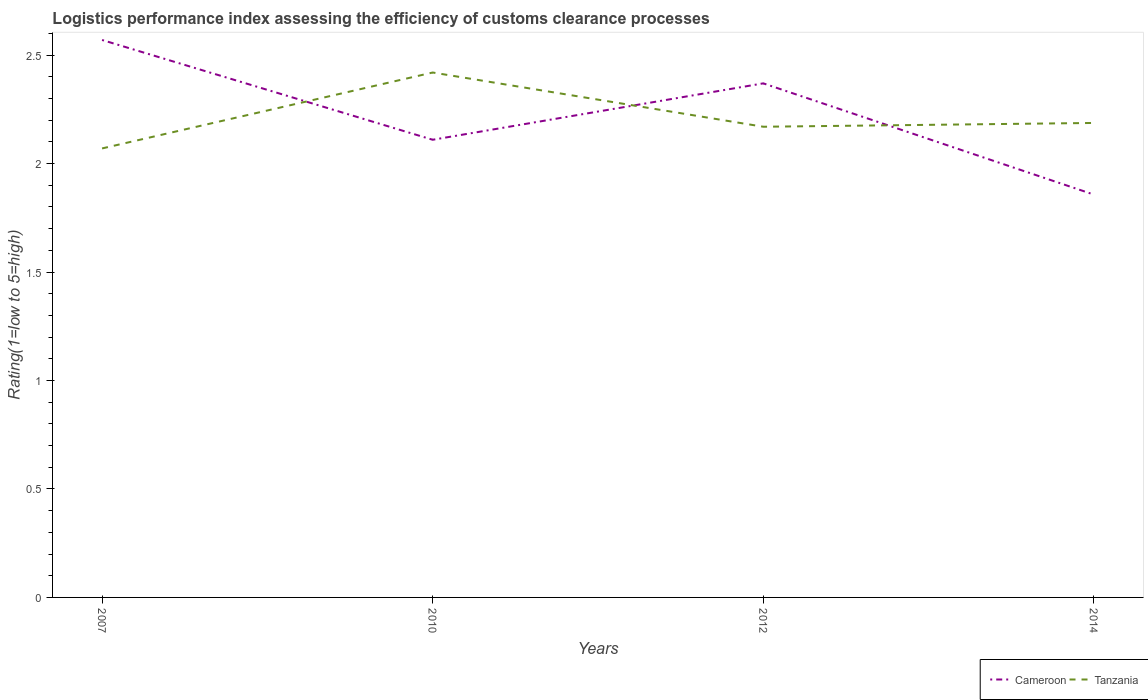How many different coloured lines are there?
Your answer should be compact. 2. Does the line corresponding to Cameroon intersect with the line corresponding to Tanzania?
Offer a very short reply. Yes. Across all years, what is the maximum Logistic performance index in Tanzania?
Offer a terse response. 2.07. What is the total Logistic performance index in Cameroon in the graph?
Your answer should be very brief. 0.46. What is the difference between the highest and the second highest Logistic performance index in Cameroon?
Your answer should be compact. 0.71. What is the difference between the highest and the lowest Logistic performance index in Tanzania?
Keep it short and to the point. 1. What is the difference between two consecutive major ticks on the Y-axis?
Provide a short and direct response. 0.5. Are the values on the major ticks of Y-axis written in scientific E-notation?
Provide a short and direct response. No. Where does the legend appear in the graph?
Offer a very short reply. Bottom right. What is the title of the graph?
Keep it short and to the point. Logistics performance index assessing the efficiency of customs clearance processes. Does "Heavily indebted poor countries" appear as one of the legend labels in the graph?
Offer a very short reply. No. What is the label or title of the X-axis?
Provide a short and direct response. Years. What is the label or title of the Y-axis?
Provide a short and direct response. Rating(1=low to 5=high). What is the Rating(1=low to 5=high) in Cameroon in 2007?
Provide a short and direct response. 2.57. What is the Rating(1=low to 5=high) in Tanzania in 2007?
Your answer should be very brief. 2.07. What is the Rating(1=low to 5=high) of Cameroon in 2010?
Ensure brevity in your answer.  2.11. What is the Rating(1=low to 5=high) in Tanzania in 2010?
Provide a short and direct response. 2.42. What is the Rating(1=low to 5=high) of Cameroon in 2012?
Your answer should be compact. 2.37. What is the Rating(1=low to 5=high) of Tanzania in 2012?
Your answer should be compact. 2.17. What is the Rating(1=low to 5=high) in Cameroon in 2014?
Ensure brevity in your answer.  1.86. What is the Rating(1=low to 5=high) in Tanzania in 2014?
Provide a short and direct response. 2.19. Across all years, what is the maximum Rating(1=low to 5=high) in Cameroon?
Offer a terse response. 2.57. Across all years, what is the maximum Rating(1=low to 5=high) in Tanzania?
Provide a succinct answer. 2.42. Across all years, what is the minimum Rating(1=low to 5=high) of Cameroon?
Give a very brief answer. 1.86. Across all years, what is the minimum Rating(1=low to 5=high) of Tanzania?
Your answer should be very brief. 2.07. What is the total Rating(1=low to 5=high) of Cameroon in the graph?
Give a very brief answer. 8.91. What is the total Rating(1=low to 5=high) in Tanzania in the graph?
Offer a very short reply. 8.85. What is the difference between the Rating(1=low to 5=high) of Cameroon in 2007 and that in 2010?
Your answer should be very brief. 0.46. What is the difference between the Rating(1=low to 5=high) in Tanzania in 2007 and that in 2010?
Offer a terse response. -0.35. What is the difference between the Rating(1=low to 5=high) in Tanzania in 2007 and that in 2012?
Ensure brevity in your answer.  -0.1. What is the difference between the Rating(1=low to 5=high) in Cameroon in 2007 and that in 2014?
Make the answer very short. 0.71. What is the difference between the Rating(1=low to 5=high) in Tanzania in 2007 and that in 2014?
Offer a very short reply. -0.12. What is the difference between the Rating(1=low to 5=high) in Cameroon in 2010 and that in 2012?
Provide a succinct answer. -0.26. What is the difference between the Rating(1=low to 5=high) of Cameroon in 2010 and that in 2014?
Provide a short and direct response. 0.25. What is the difference between the Rating(1=low to 5=high) of Tanzania in 2010 and that in 2014?
Provide a short and direct response. 0.23. What is the difference between the Rating(1=low to 5=high) in Cameroon in 2012 and that in 2014?
Give a very brief answer. 0.51. What is the difference between the Rating(1=low to 5=high) in Tanzania in 2012 and that in 2014?
Your answer should be compact. -0.02. What is the difference between the Rating(1=low to 5=high) of Cameroon in 2007 and the Rating(1=low to 5=high) of Tanzania in 2010?
Your answer should be compact. 0.15. What is the difference between the Rating(1=low to 5=high) of Cameroon in 2007 and the Rating(1=low to 5=high) of Tanzania in 2012?
Keep it short and to the point. 0.4. What is the difference between the Rating(1=low to 5=high) of Cameroon in 2007 and the Rating(1=low to 5=high) of Tanzania in 2014?
Provide a short and direct response. 0.38. What is the difference between the Rating(1=low to 5=high) of Cameroon in 2010 and the Rating(1=low to 5=high) of Tanzania in 2012?
Give a very brief answer. -0.06. What is the difference between the Rating(1=low to 5=high) of Cameroon in 2010 and the Rating(1=low to 5=high) of Tanzania in 2014?
Offer a terse response. -0.08. What is the difference between the Rating(1=low to 5=high) of Cameroon in 2012 and the Rating(1=low to 5=high) of Tanzania in 2014?
Your answer should be compact. 0.18. What is the average Rating(1=low to 5=high) in Cameroon per year?
Make the answer very short. 2.23. What is the average Rating(1=low to 5=high) of Tanzania per year?
Make the answer very short. 2.21. In the year 2007, what is the difference between the Rating(1=low to 5=high) in Cameroon and Rating(1=low to 5=high) in Tanzania?
Your answer should be very brief. 0.5. In the year 2010, what is the difference between the Rating(1=low to 5=high) of Cameroon and Rating(1=low to 5=high) of Tanzania?
Make the answer very short. -0.31. In the year 2014, what is the difference between the Rating(1=low to 5=high) of Cameroon and Rating(1=low to 5=high) of Tanzania?
Ensure brevity in your answer.  -0.33. What is the ratio of the Rating(1=low to 5=high) of Cameroon in 2007 to that in 2010?
Provide a succinct answer. 1.22. What is the ratio of the Rating(1=low to 5=high) in Tanzania in 2007 to that in 2010?
Provide a succinct answer. 0.86. What is the ratio of the Rating(1=low to 5=high) in Cameroon in 2007 to that in 2012?
Provide a succinct answer. 1.08. What is the ratio of the Rating(1=low to 5=high) in Tanzania in 2007 to that in 2012?
Give a very brief answer. 0.95. What is the ratio of the Rating(1=low to 5=high) in Cameroon in 2007 to that in 2014?
Offer a very short reply. 1.38. What is the ratio of the Rating(1=low to 5=high) in Tanzania in 2007 to that in 2014?
Offer a very short reply. 0.95. What is the ratio of the Rating(1=low to 5=high) of Cameroon in 2010 to that in 2012?
Make the answer very short. 0.89. What is the ratio of the Rating(1=low to 5=high) of Tanzania in 2010 to that in 2012?
Offer a terse response. 1.12. What is the ratio of the Rating(1=low to 5=high) in Cameroon in 2010 to that in 2014?
Provide a succinct answer. 1.14. What is the ratio of the Rating(1=low to 5=high) in Tanzania in 2010 to that in 2014?
Ensure brevity in your answer.  1.11. What is the ratio of the Rating(1=low to 5=high) in Cameroon in 2012 to that in 2014?
Your answer should be very brief. 1.28. What is the difference between the highest and the second highest Rating(1=low to 5=high) of Tanzania?
Ensure brevity in your answer.  0.23. What is the difference between the highest and the lowest Rating(1=low to 5=high) of Cameroon?
Offer a terse response. 0.71. What is the difference between the highest and the lowest Rating(1=low to 5=high) in Tanzania?
Your answer should be very brief. 0.35. 